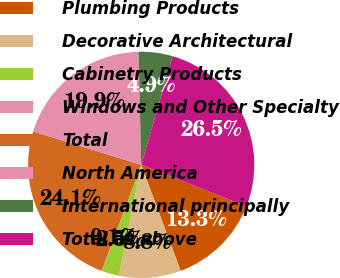Convert chart to OTSL. <chart><loc_0><loc_0><loc_500><loc_500><pie_chart><fcel>Plumbing Products<fcel>Decorative Architectural<fcel>Cabinetry Products<fcel>Windows and Other Specialty<fcel>Total<fcel>North America<fcel>International principally<fcel>Total as above<nl><fcel>13.34%<fcel>8.83%<fcel>2.46%<fcel>0.06%<fcel>24.09%<fcel>19.85%<fcel>4.87%<fcel>26.49%<nl></chart> 